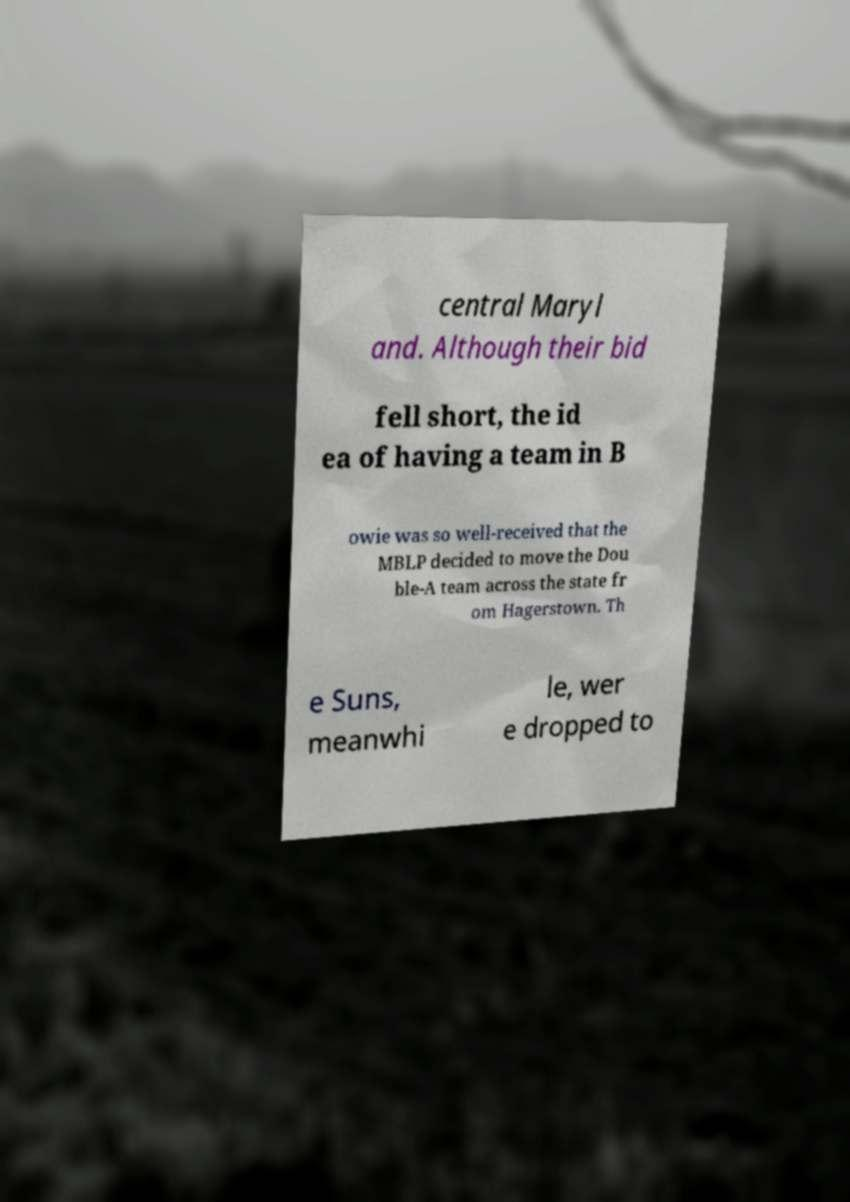Can you read and provide the text displayed in the image?This photo seems to have some interesting text. Can you extract and type it out for me? central Maryl and. Although their bid fell short, the id ea of having a team in B owie was so well-received that the MBLP decided to move the Dou ble-A team across the state fr om Hagerstown. Th e Suns, meanwhi le, wer e dropped to 